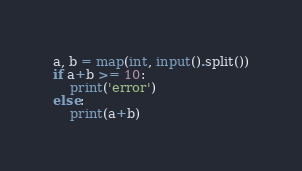Convert code to text. <code><loc_0><loc_0><loc_500><loc_500><_Python_>a, b = map(int, input().split())
if a+b >= 10:
    print('error')
else:
    print(a+b)</code> 